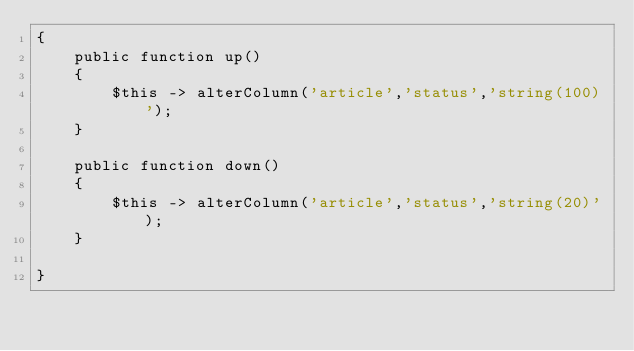<code> <loc_0><loc_0><loc_500><loc_500><_PHP_>{
    public function up()
    {
        $this -> alterColumn('article','status','string(100)');
    }

    public function down()
    {
        $this -> alterColumn('article','status','string(20)');
    }

}
</code> 